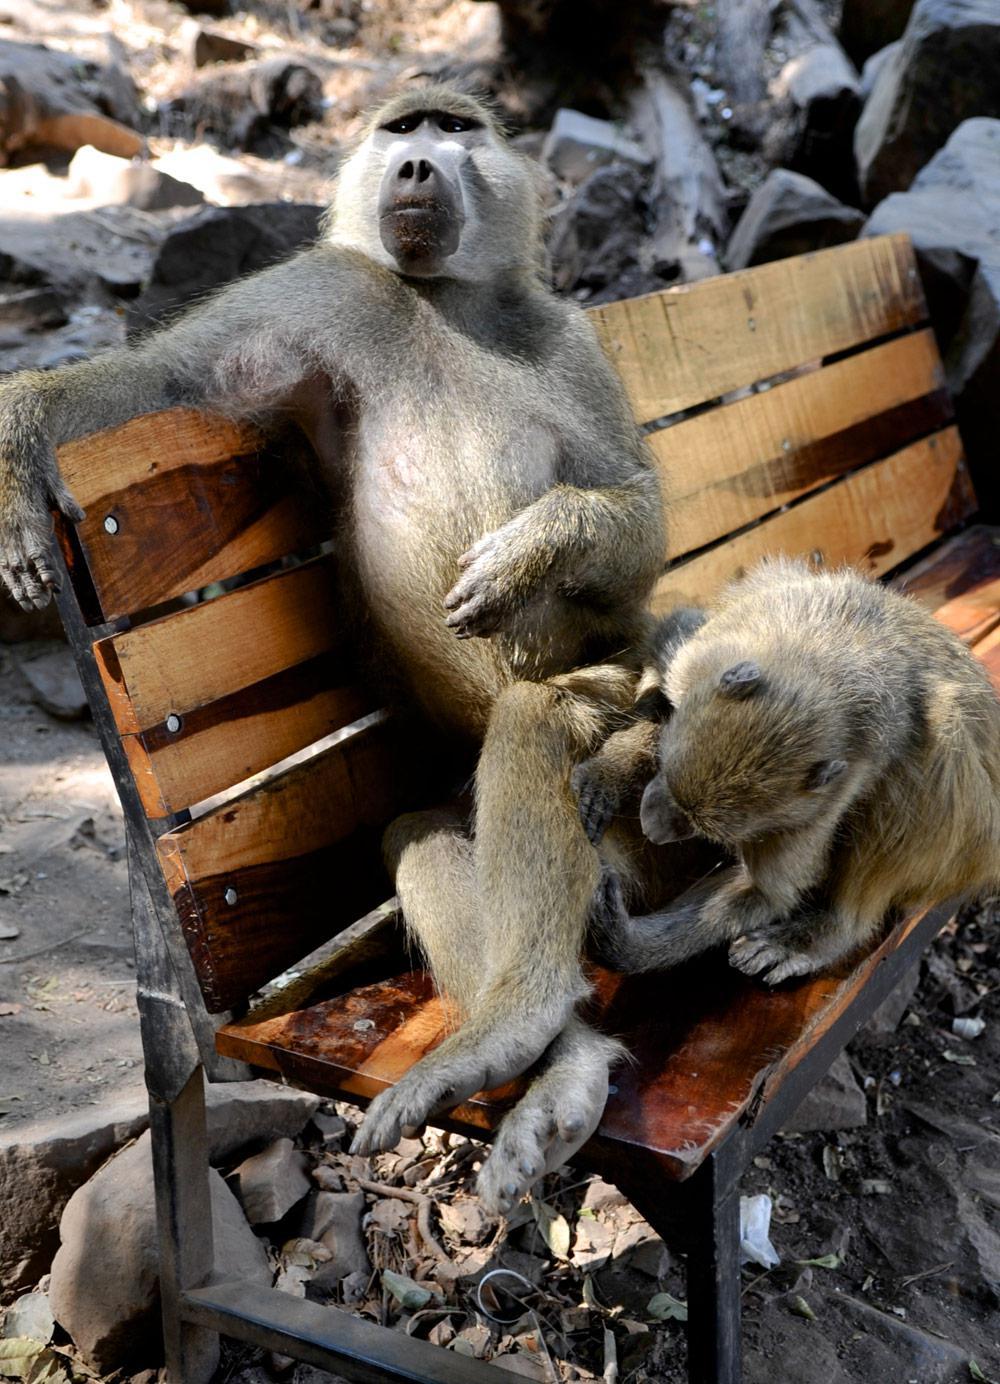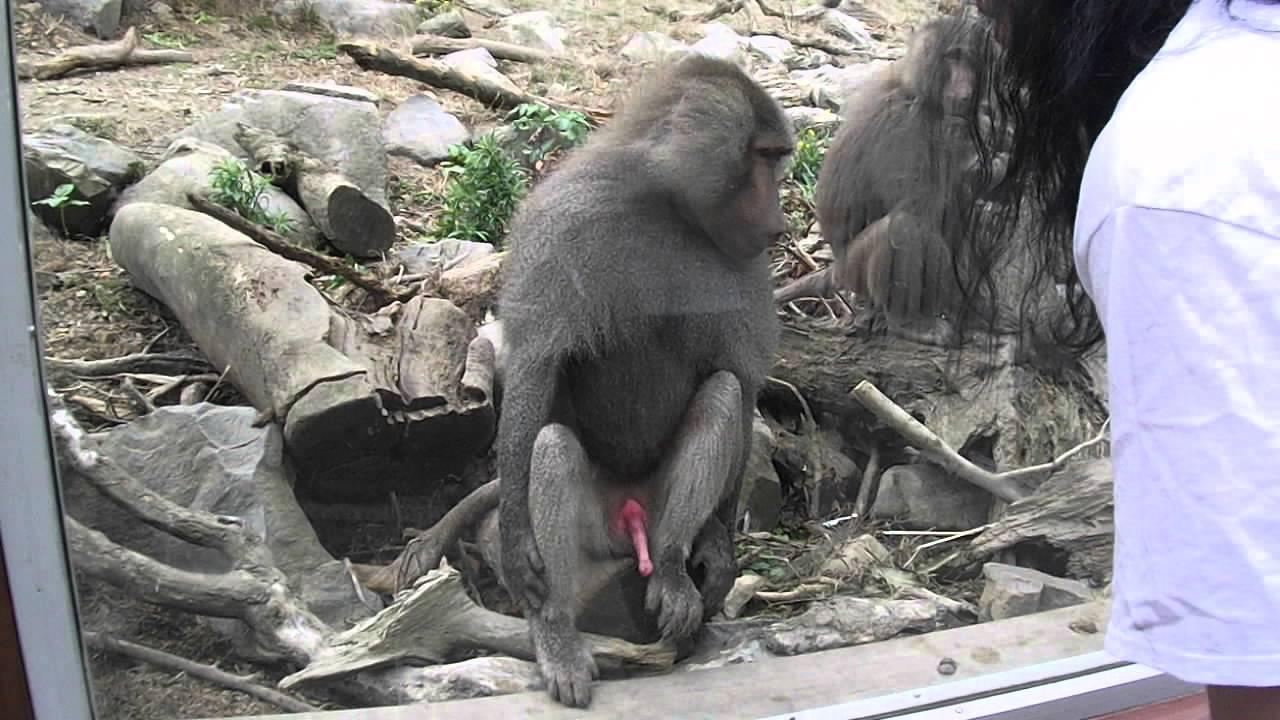The first image is the image on the left, the second image is the image on the right. Given the left and right images, does the statement "There are at most two baboons." hold true? Answer yes or no. No. The first image is the image on the left, the second image is the image on the right. For the images shown, is this caption "There are at most two baboons." true? Answer yes or no. No. 